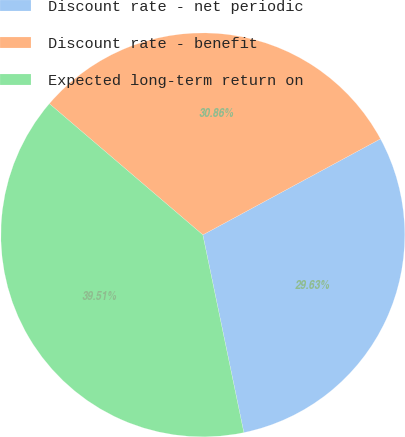<chart> <loc_0><loc_0><loc_500><loc_500><pie_chart><fcel>Discount rate - net periodic<fcel>Discount rate - benefit<fcel>Expected long-term return on<nl><fcel>29.63%<fcel>30.86%<fcel>39.51%<nl></chart> 